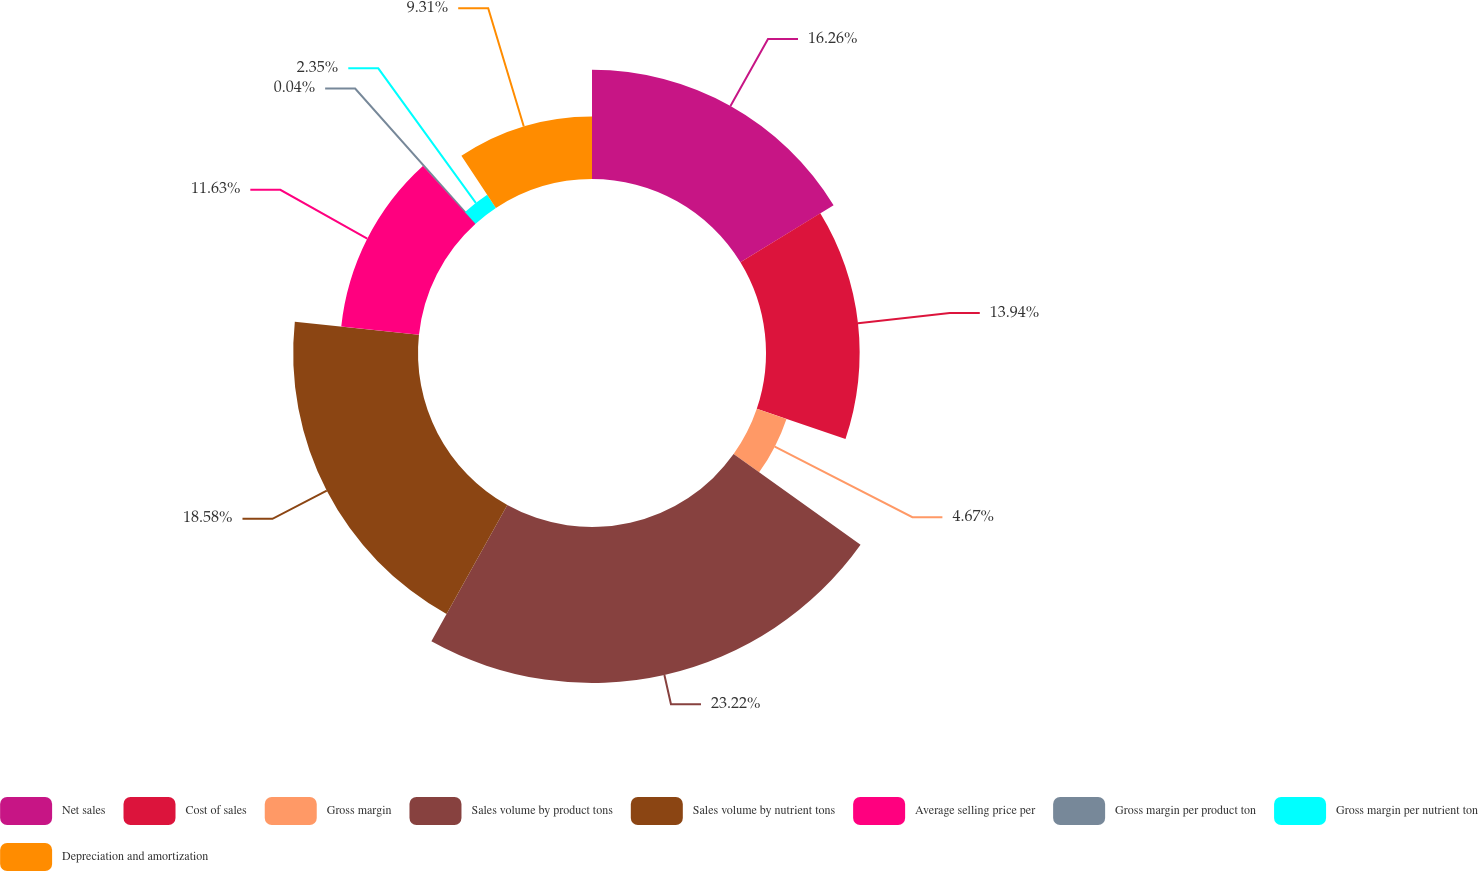<chart> <loc_0><loc_0><loc_500><loc_500><pie_chart><fcel>Net sales<fcel>Cost of sales<fcel>Gross margin<fcel>Sales volume by product tons<fcel>Sales volume by nutrient tons<fcel>Average selling price per<fcel>Gross margin per product ton<fcel>Gross margin per nutrient ton<fcel>Depreciation and amortization<nl><fcel>16.26%<fcel>13.94%<fcel>4.67%<fcel>23.22%<fcel>18.58%<fcel>11.63%<fcel>0.04%<fcel>2.35%<fcel>9.31%<nl></chart> 